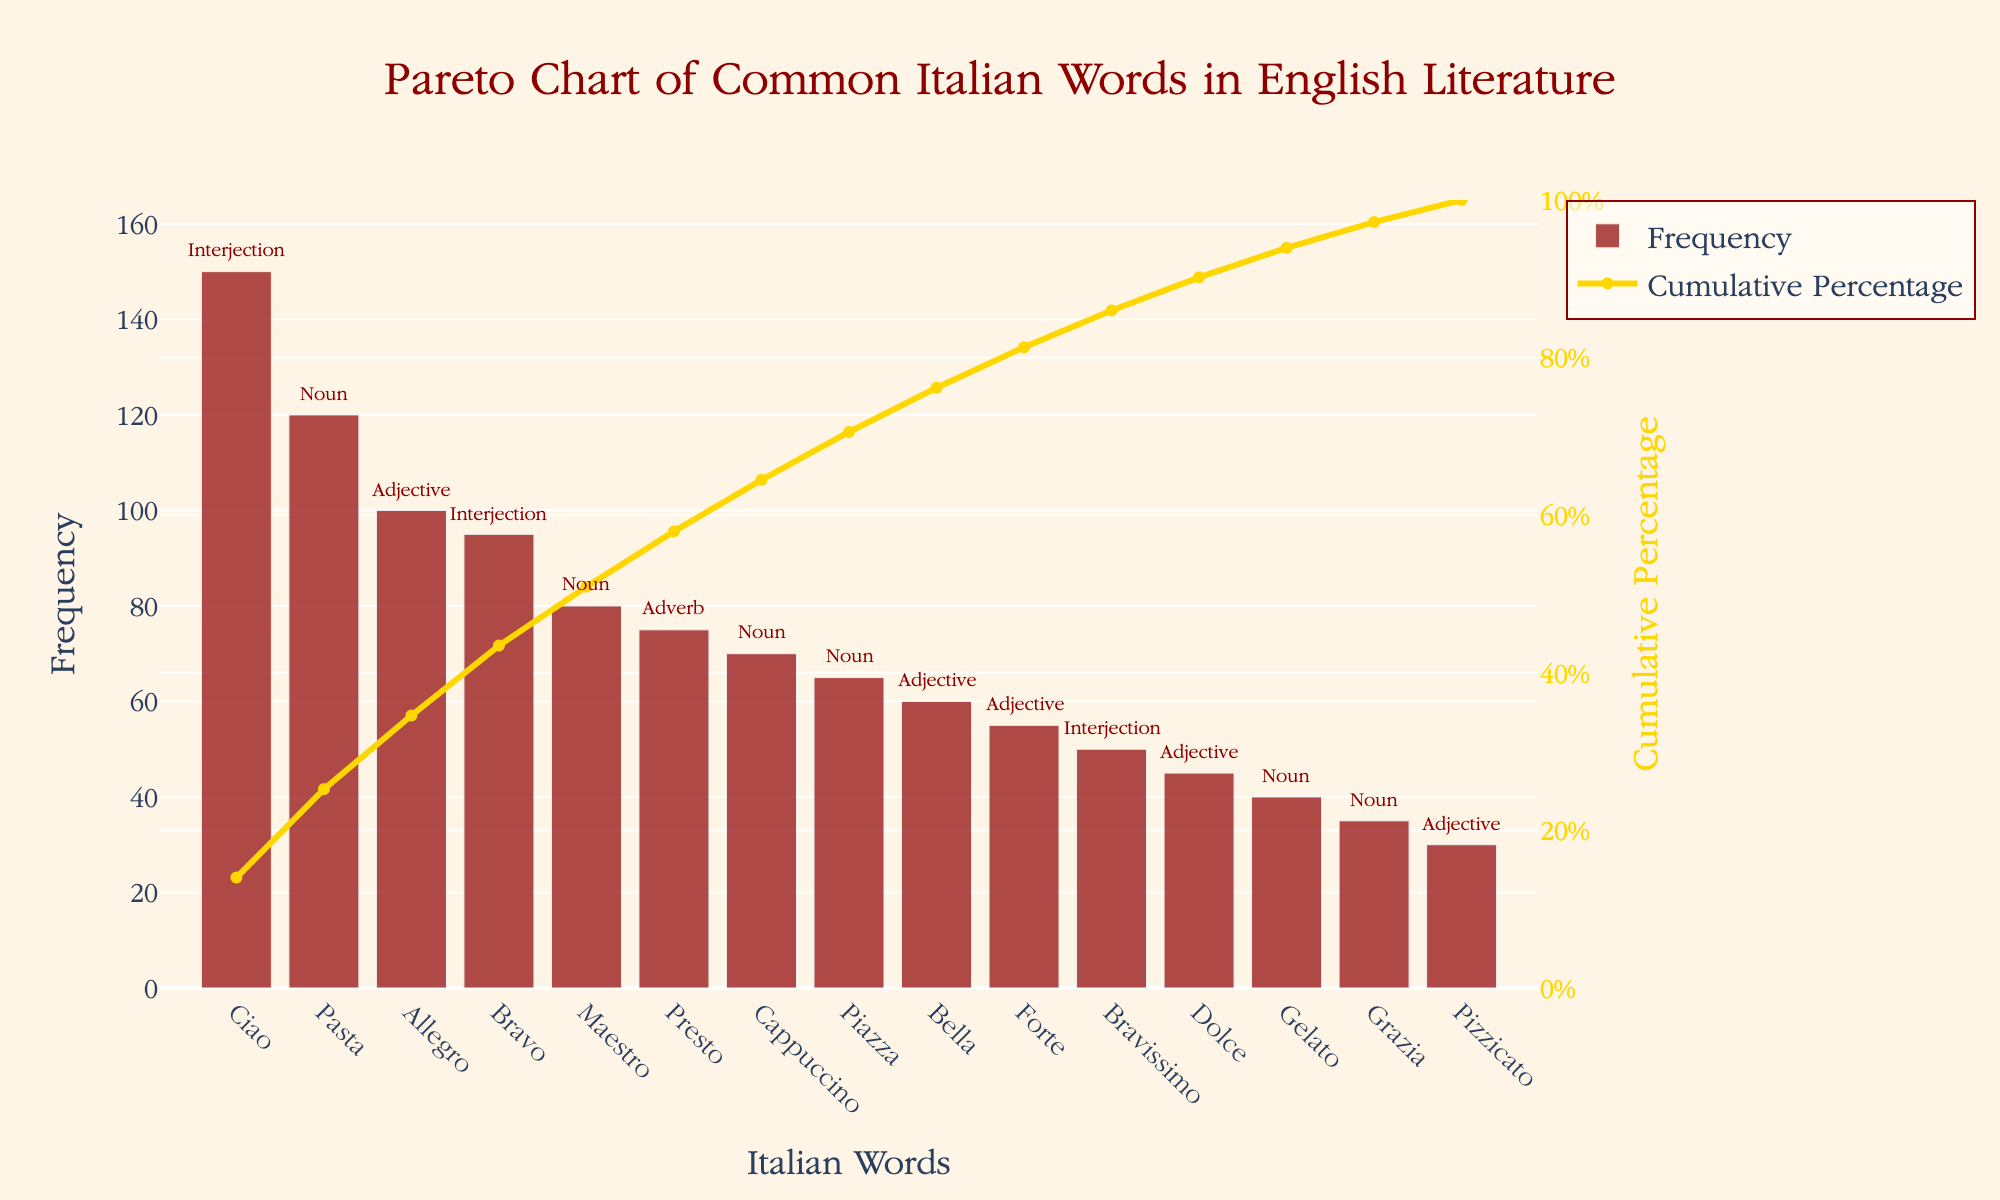What is the title of the chart? The title is positioned at the top of the chart and is in a larger font size, titled, "Pareto Chart of Common Italian Words in English Literature."
Answer: Pareto Chart of Common Italian Words in English Literature What word appears most frequently in English literature among the common Italian words? The word with the highest bar represents the highest frequency. In this case, it is "Ciao."
Answer: Ciao At what cumulative percentage do the top three words account for? The cumulative percentage line helps in determining how much percentage is covered by the top words. "Ciao" (150), "Pasta" (120), and "Allegro" (100) add up to 370. The total frequency sum is 1,170 (sum of frequencies of all words). Thus, 370/1,170 * 100 = 31.62%.
Answer: Approximately 31.6% Which words are categorized as interjections and what are their frequencies? Annotations next to the bars specify the Part of Speech. The words tagged as "Interjection" are "Ciao," "Bravo," and "Bravissimo" with frequencies 150, 95, and 50, respectively.
Answer: "Ciao" (150), "Bravo" (95), "Bravissimo" (50) How many nouns are listed and what is their combined frequency? Look at the annotations to count the words categorized as "Noun" and sum their frequencies: "Pasta" (120), "Maestro" (80), "Cappuccino" (70), "Piazza" (65), "Gelato" (40), "Grazia" (35). The combined frequency is 120+80+70+65+40+35 = 410.
Answer: 6 nouns, 410 frequency Which adjective has the highest frequency and what is its value? Check the labels and annotations for "Adjective" and compare the frequencies. "Allegro" has the highest frequency among adjectives with a value of 100.
Answer: Allegro (100) What is the cumulative frequency for the word "Maestro"? To find the cumulative frequency, sum the frequencies of all words from the start up to "Maestro": 150 (Ciao) + 120 (Pasta) + 100 (Allegro) + 95 (Bravo) + 80 (Maestro). This adds up to 545.
Answer: 545 Which word has a cumulative percentage just above 50% and what is its frequency? The cumulative percentage line: Calculate and observe positions. Just above 50% is "Bella." Frequency = 60.
Answer: Bella (60) Is "Dolce" more frequently used than "Forte"? Compare the bar heights or numerical frequencies of "Dolce" and "Forte." "Forte" has 55 while "Dolce" has 45. Hence, "Forte" is more frequently used.
Answer: No What part of speech is the word "Piazza" and what is its frequency? The annotation next to "Piazza" specifies Part of Speech as "Noun" with a frequency of 65.
Answer: Noun (65) 